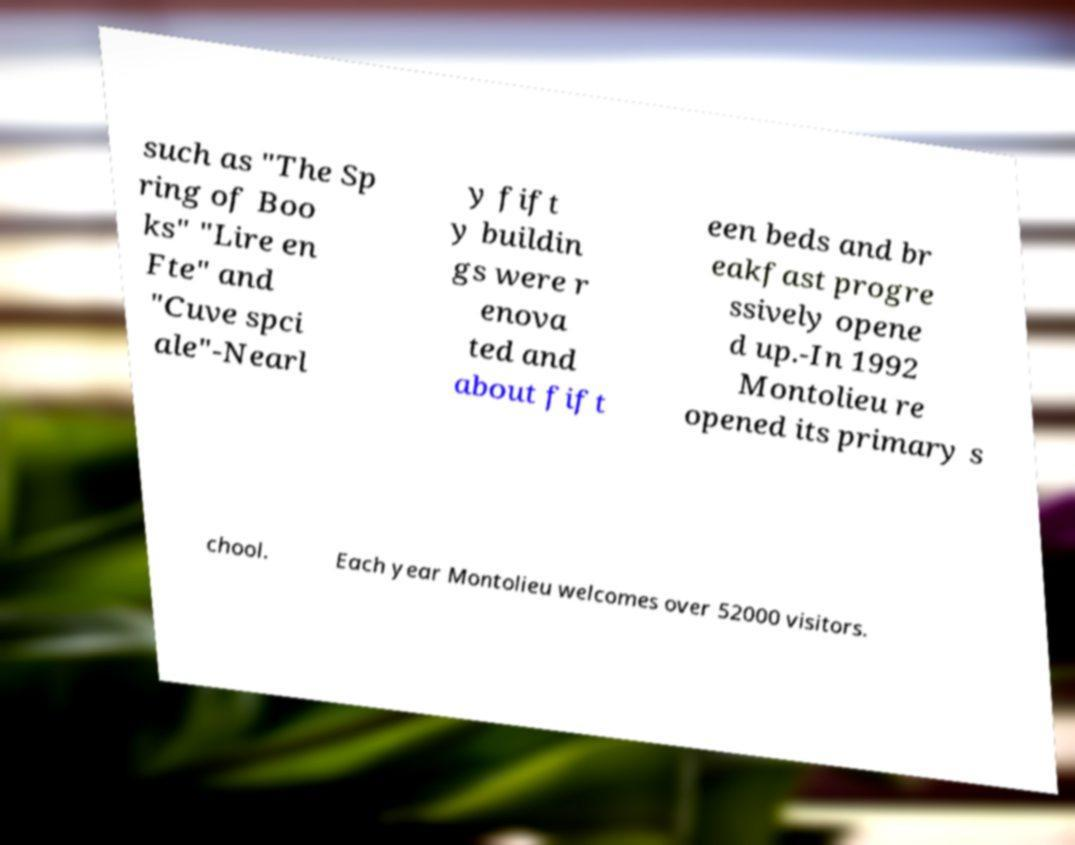Can you read and provide the text displayed in the image?This photo seems to have some interesting text. Can you extract and type it out for me? such as "The Sp ring of Boo ks" "Lire en Fte" and "Cuve spci ale"-Nearl y fift y buildin gs were r enova ted and about fift een beds and br eakfast progre ssively opene d up.-In 1992 Montolieu re opened its primary s chool. Each year Montolieu welcomes over 52000 visitors. 